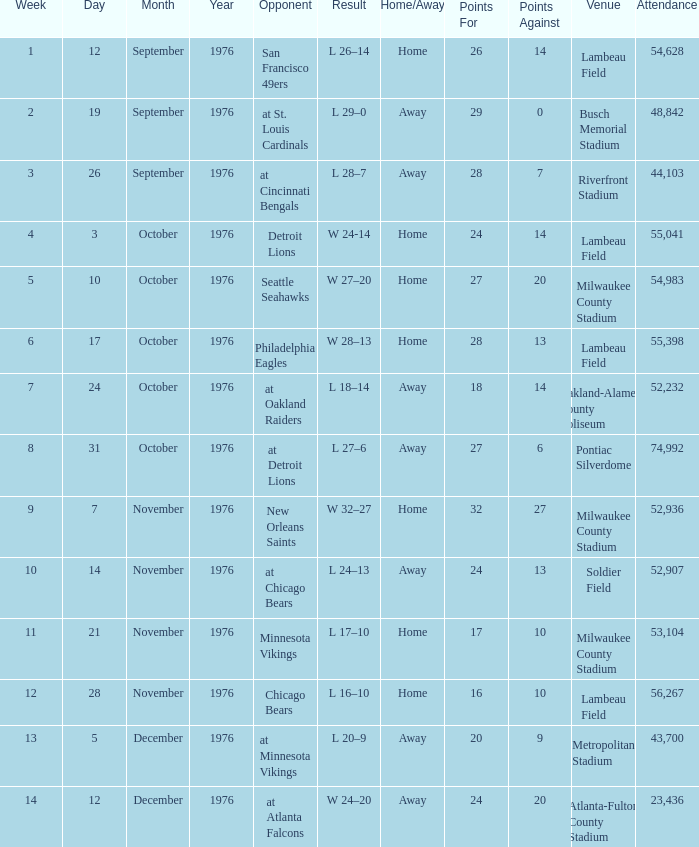What is the average attendance for the game on September 26, 1976? 44103.0. 